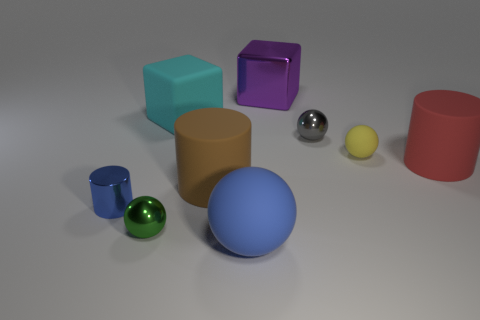What size is the metal sphere on the left side of the rubber thing behind the metal ball behind the tiny blue metal thing?
Provide a succinct answer. Small. How big is the block on the right side of the big blue sphere?
Your answer should be very brief. Large. What number of cyan objects are tiny cylinders or large shiny blocks?
Keep it short and to the point. 0. Is there a cyan matte ball that has the same size as the yellow ball?
Provide a succinct answer. No. There is a ball that is the same size as the purple thing; what is it made of?
Your response must be concise. Rubber. Do the matte cylinder to the left of the purple thing and the cube right of the blue rubber ball have the same size?
Give a very brief answer. Yes. What number of objects are small blue cylinders or objects on the right side of the green metal thing?
Offer a terse response. 8. Are there any small brown metallic things that have the same shape as the big purple thing?
Your response must be concise. No. There is a rubber object behind the small shiny sphere that is behind the blue shiny object; what is its size?
Offer a terse response. Large. Is the color of the rubber cube the same as the tiny shiny cylinder?
Your answer should be compact. No. 